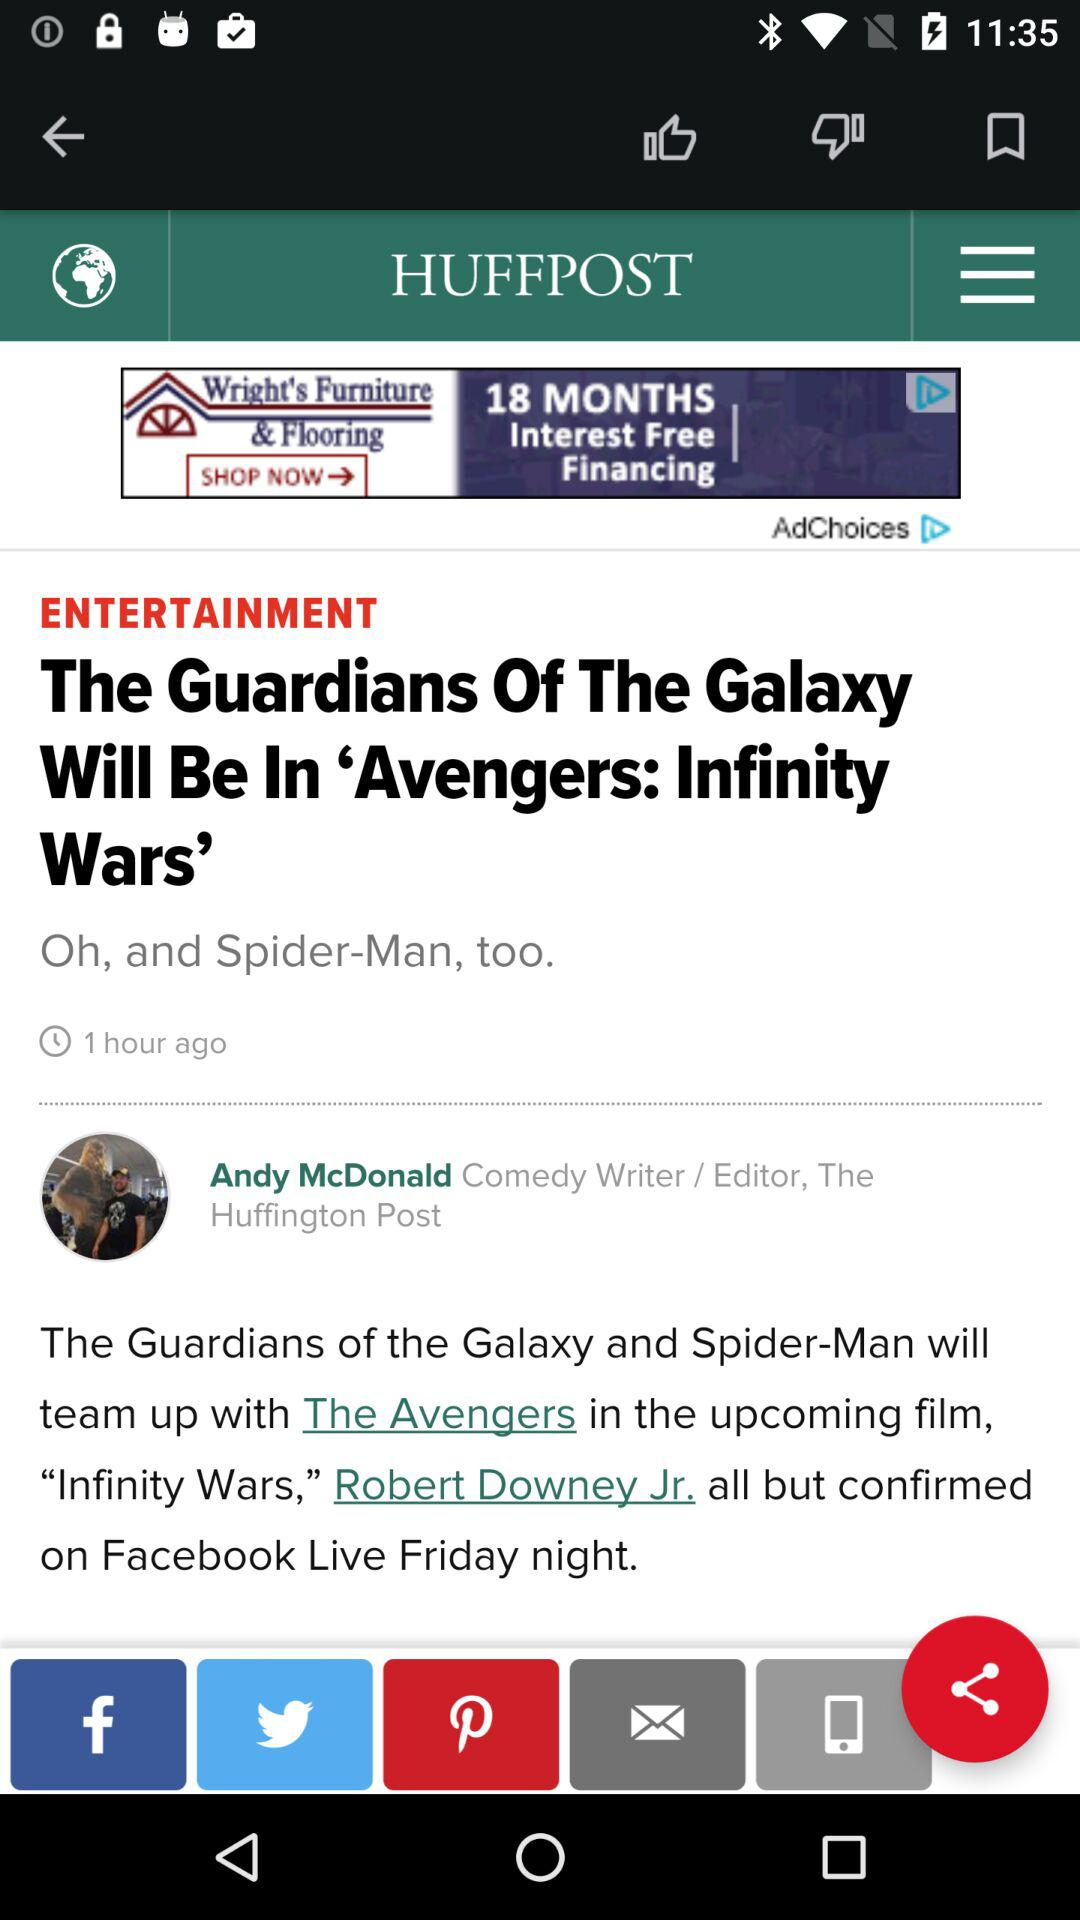Who is the editor of this article? The editor of the article is "Andy McDonald". 